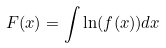Convert formula to latex. <formula><loc_0><loc_0><loc_500><loc_500>F ( x ) = \int \ln ( f ( x ) ) d x</formula> 